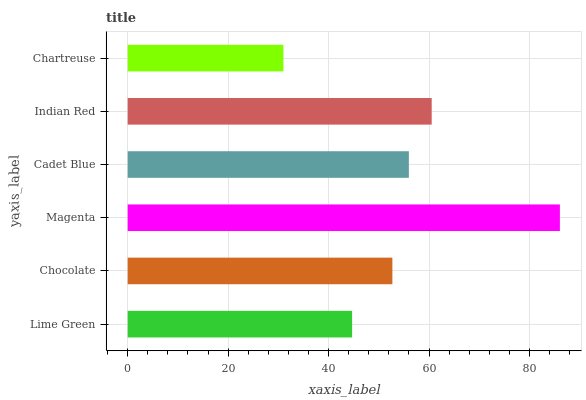Is Chartreuse the minimum?
Answer yes or no. Yes. Is Magenta the maximum?
Answer yes or no. Yes. Is Chocolate the minimum?
Answer yes or no. No. Is Chocolate the maximum?
Answer yes or no. No. Is Chocolate greater than Lime Green?
Answer yes or no. Yes. Is Lime Green less than Chocolate?
Answer yes or no. Yes. Is Lime Green greater than Chocolate?
Answer yes or no. No. Is Chocolate less than Lime Green?
Answer yes or no. No. Is Cadet Blue the high median?
Answer yes or no. Yes. Is Chocolate the low median?
Answer yes or no. Yes. Is Chocolate the high median?
Answer yes or no. No. Is Lime Green the low median?
Answer yes or no. No. 